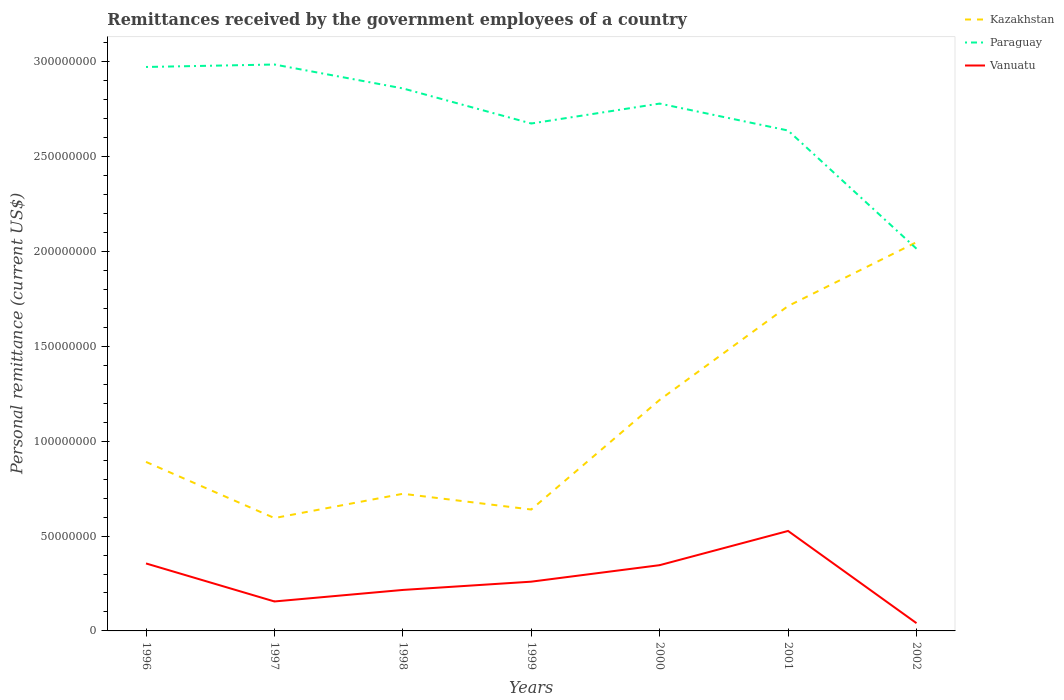Does the line corresponding to Kazakhstan intersect with the line corresponding to Vanuatu?
Make the answer very short. No. Across all years, what is the maximum remittances received by the government employees in Vanuatu?
Provide a short and direct response. 4.10e+06. What is the total remittances received by the government employees in Paraguay in the graph?
Your answer should be very brief. 3.70e+06. What is the difference between the highest and the second highest remittances received by the government employees in Paraguay?
Your answer should be very brief. 9.71e+07. How many lines are there?
Provide a succinct answer. 3. How many years are there in the graph?
Give a very brief answer. 7. Are the values on the major ticks of Y-axis written in scientific E-notation?
Provide a succinct answer. No. Where does the legend appear in the graph?
Offer a terse response. Top right. How are the legend labels stacked?
Give a very brief answer. Vertical. What is the title of the graph?
Offer a terse response. Remittances received by the government employees of a country. Does "Trinidad and Tobago" appear as one of the legend labels in the graph?
Offer a terse response. No. What is the label or title of the Y-axis?
Your answer should be compact. Personal remittance (current US$). What is the Personal remittance (current US$) of Kazakhstan in 1996?
Make the answer very short. 8.91e+07. What is the Personal remittance (current US$) in Paraguay in 1996?
Give a very brief answer. 2.97e+08. What is the Personal remittance (current US$) in Vanuatu in 1996?
Your response must be concise. 3.56e+07. What is the Personal remittance (current US$) of Kazakhstan in 1997?
Give a very brief answer. 5.95e+07. What is the Personal remittance (current US$) of Paraguay in 1997?
Offer a terse response. 2.99e+08. What is the Personal remittance (current US$) in Vanuatu in 1997?
Provide a short and direct response. 1.55e+07. What is the Personal remittance (current US$) of Kazakhstan in 1998?
Your answer should be very brief. 7.23e+07. What is the Personal remittance (current US$) in Paraguay in 1998?
Ensure brevity in your answer.  2.86e+08. What is the Personal remittance (current US$) of Vanuatu in 1998?
Your answer should be compact. 2.16e+07. What is the Personal remittance (current US$) of Kazakhstan in 1999?
Provide a succinct answer. 6.40e+07. What is the Personal remittance (current US$) of Paraguay in 1999?
Provide a short and direct response. 2.68e+08. What is the Personal remittance (current US$) of Vanuatu in 1999?
Provide a succinct answer. 2.60e+07. What is the Personal remittance (current US$) of Kazakhstan in 2000?
Make the answer very short. 1.22e+08. What is the Personal remittance (current US$) of Paraguay in 2000?
Your answer should be compact. 2.78e+08. What is the Personal remittance (current US$) of Vanuatu in 2000?
Give a very brief answer. 3.47e+07. What is the Personal remittance (current US$) in Kazakhstan in 2001?
Make the answer very short. 1.71e+08. What is the Personal remittance (current US$) in Paraguay in 2001?
Provide a short and direct response. 2.64e+08. What is the Personal remittance (current US$) of Vanuatu in 2001?
Keep it short and to the point. 5.27e+07. What is the Personal remittance (current US$) in Kazakhstan in 2002?
Ensure brevity in your answer.  2.05e+08. What is the Personal remittance (current US$) of Paraguay in 2002?
Ensure brevity in your answer.  2.02e+08. What is the Personal remittance (current US$) in Vanuatu in 2002?
Provide a short and direct response. 4.10e+06. Across all years, what is the maximum Personal remittance (current US$) of Kazakhstan?
Your answer should be very brief. 2.05e+08. Across all years, what is the maximum Personal remittance (current US$) in Paraguay?
Provide a short and direct response. 2.99e+08. Across all years, what is the maximum Personal remittance (current US$) of Vanuatu?
Your answer should be compact. 5.27e+07. Across all years, what is the minimum Personal remittance (current US$) in Kazakhstan?
Provide a succinct answer. 5.95e+07. Across all years, what is the minimum Personal remittance (current US$) in Paraguay?
Your response must be concise. 2.02e+08. Across all years, what is the minimum Personal remittance (current US$) of Vanuatu?
Ensure brevity in your answer.  4.10e+06. What is the total Personal remittance (current US$) of Kazakhstan in the graph?
Offer a very short reply. 7.83e+08. What is the total Personal remittance (current US$) of Paraguay in the graph?
Offer a very short reply. 1.89e+09. What is the total Personal remittance (current US$) in Vanuatu in the graph?
Ensure brevity in your answer.  1.90e+08. What is the difference between the Personal remittance (current US$) of Kazakhstan in 1996 and that in 1997?
Make the answer very short. 2.96e+07. What is the difference between the Personal remittance (current US$) in Paraguay in 1996 and that in 1997?
Provide a succinct answer. -1.30e+06. What is the difference between the Personal remittance (current US$) in Vanuatu in 1996 and that in 1997?
Offer a very short reply. 2.00e+07. What is the difference between the Personal remittance (current US$) in Kazakhstan in 1996 and that in 1998?
Ensure brevity in your answer.  1.68e+07. What is the difference between the Personal remittance (current US$) of Paraguay in 1996 and that in 1998?
Offer a very short reply. 1.13e+07. What is the difference between the Personal remittance (current US$) in Vanuatu in 1996 and that in 1998?
Ensure brevity in your answer.  1.40e+07. What is the difference between the Personal remittance (current US$) of Kazakhstan in 1996 and that in 1999?
Your answer should be very brief. 2.51e+07. What is the difference between the Personal remittance (current US$) of Paraguay in 1996 and that in 1999?
Give a very brief answer. 2.98e+07. What is the difference between the Personal remittance (current US$) in Vanuatu in 1996 and that in 1999?
Provide a succinct answer. 9.60e+06. What is the difference between the Personal remittance (current US$) of Kazakhstan in 1996 and that in 2000?
Provide a succinct answer. -3.27e+07. What is the difference between the Personal remittance (current US$) of Paraguay in 1996 and that in 2000?
Offer a terse response. 1.93e+07. What is the difference between the Personal remittance (current US$) of Vanuatu in 1996 and that in 2000?
Provide a succinct answer. 9.06e+05. What is the difference between the Personal remittance (current US$) in Kazakhstan in 1996 and that in 2001?
Provide a succinct answer. -8.22e+07. What is the difference between the Personal remittance (current US$) of Paraguay in 1996 and that in 2001?
Ensure brevity in your answer.  3.35e+07. What is the difference between the Personal remittance (current US$) in Vanuatu in 1996 and that in 2001?
Give a very brief answer. -1.71e+07. What is the difference between the Personal remittance (current US$) of Kazakhstan in 1996 and that in 2002?
Offer a very short reply. -1.16e+08. What is the difference between the Personal remittance (current US$) in Paraguay in 1996 and that in 2002?
Keep it short and to the point. 9.58e+07. What is the difference between the Personal remittance (current US$) of Vanuatu in 1996 and that in 2002?
Offer a very short reply. 3.15e+07. What is the difference between the Personal remittance (current US$) in Kazakhstan in 1997 and that in 1998?
Your response must be concise. -1.28e+07. What is the difference between the Personal remittance (current US$) in Paraguay in 1997 and that in 1998?
Provide a succinct answer. 1.26e+07. What is the difference between the Personal remittance (current US$) of Vanuatu in 1997 and that in 1998?
Your answer should be compact. -6.08e+06. What is the difference between the Personal remittance (current US$) in Kazakhstan in 1997 and that in 1999?
Make the answer very short. -4.50e+06. What is the difference between the Personal remittance (current US$) in Paraguay in 1997 and that in 1999?
Keep it short and to the point. 3.11e+07. What is the difference between the Personal remittance (current US$) in Vanuatu in 1997 and that in 1999?
Keep it short and to the point. -1.04e+07. What is the difference between the Personal remittance (current US$) in Kazakhstan in 1997 and that in 2000?
Your response must be concise. -6.23e+07. What is the difference between the Personal remittance (current US$) in Paraguay in 1997 and that in 2000?
Keep it short and to the point. 2.06e+07. What is the difference between the Personal remittance (current US$) of Vanuatu in 1997 and that in 2000?
Your answer should be compact. -1.91e+07. What is the difference between the Personal remittance (current US$) in Kazakhstan in 1997 and that in 2001?
Provide a succinct answer. -1.12e+08. What is the difference between the Personal remittance (current US$) in Paraguay in 1997 and that in 2001?
Offer a very short reply. 3.48e+07. What is the difference between the Personal remittance (current US$) in Vanuatu in 1997 and that in 2001?
Ensure brevity in your answer.  -3.72e+07. What is the difference between the Personal remittance (current US$) in Kazakhstan in 1997 and that in 2002?
Offer a terse response. -1.45e+08. What is the difference between the Personal remittance (current US$) of Paraguay in 1997 and that in 2002?
Provide a short and direct response. 9.71e+07. What is the difference between the Personal remittance (current US$) in Vanuatu in 1997 and that in 2002?
Offer a terse response. 1.14e+07. What is the difference between the Personal remittance (current US$) of Kazakhstan in 1998 and that in 1999?
Ensure brevity in your answer.  8.30e+06. What is the difference between the Personal remittance (current US$) of Paraguay in 1998 and that in 1999?
Provide a succinct answer. 1.85e+07. What is the difference between the Personal remittance (current US$) of Vanuatu in 1998 and that in 1999?
Keep it short and to the point. -4.36e+06. What is the difference between the Personal remittance (current US$) of Kazakhstan in 1998 and that in 2000?
Ensure brevity in your answer.  -4.95e+07. What is the difference between the Personal remittance (current US$) of Vanuatu in 1998 and that in 2000?
Keep it short and to the point. -1.31e+07. What is the difference between the Personal remittance (current US$) in Kazakhstan in 1998 and that in 2001?
Offer a terse response. -9.90e+07. What is the difference between the Personal remittance (current US$) of Paraguay in 1998 and that in 2001?
Offer a very short reply. 2.22e+07. What is the difference between the Personal remittance (current US$) in Vanuatu in 1998 and that in 2001?
Your answer should be compact. -3.11e+07. What is the difference between the Personal remittance (current US$) in Kazakhstan in 1998 and that in 2002?
Your answer should be compact. -1.33e+08. What is the difference between the Personal remittance (current US$) of Paraguay in 1998 and that in 2002?
Your response must be concise. 8.45e+07. What is the difference between the Personal remittance (current US$) in Vanuatu in 1998 and that in 2002?
Offer a terse response. 1.75e+07. What is the difference between the Personal remittance (current US$) in Kazakhstan in 1999 and that in 2000?
Offer a terse response. -5.78e+07. What is the difference between the Personal remittance (current US$) in Paraguay in 1999 and that in 2000?
Your response must be concise. -1.05e+07. What is the difference between the Personal remittance (current US$) in Vanuatu in 1999 and that in 2000?
Keep it short and to the point. -8.70e+06. What is the difference between the Personal remittance (current US$) of Kazakhstan in 1999 and that in 2001?
Your answer should be compact. -1.07e+08. What is the difference between the Personal remittance (current US$) of Paraguay in 1999 and that in 2001?
Offer a very short reply. 3.70e+06. What is the difference between the Personal remittance (current US$) in Vanuatu in 1999 and that in 2001?
Your response must be concise. -2.67e+07. What is the difference between the Personal remittance (current US$) of Kazakhstan in 1999 and that in 2002?
Ensure brevity in your answer.  -1.41e+08. What is the difference between the Personal remittance (current US$) of Paraguay in 1999 and that in 2002?
Provide a succinct answer. 6.60e+07. What is the difference between the Personal remittance (current US$) of Vanuatu in 1999 and that in 2002?
Provide a short and direct response. 2.19e+07. What is the difference between the Personal remittance (current US$) of Kazakhstan in 2000 and that in 2001?
Make the answer very short. -4.95e+07. What is the difference between the Personal remittance (current US$) of Paraguay in 2000 and that in 2001?
Offer a very short reply. 1.42e+07. What is the difference between the Personal remittance (current US$) of Vanuatu in 2000 and that in 2001?
Your answer should be compact. -1.80e+07. What is the difference between the Personal remittance (current US$) in Kazakhstan in 2000 and that in 2002?
Give a very brief answer. -8.31e+07. What is the difference between the Personal remittance (current US$) of Paraguay in 2000 and that in 2002?
Your answer should be very brief. 7.65e+07. What is the difference between the Personal remittance (current US$) in Vanuatu in 2000 and that in 2002?
Your answer should be very brief. 3.06e+07. What is the difference between the Personal remittance (current US$) in Kazakhstan in 2001 and that in 2002?
Your answer should be compact. -3.37e+07. What is the difference between the Personal remittance (current US$) in Paraguay in 2001 and that in 2002?
Your answer should be very brief. 6.23e+07. What is the difference between the Personal remittance (current US$) in Vanuatu in 2001 and that in 2002?
Your answer should be very brief. 4.86e+07. What is the difference between the Personal remittance (current US$) in Kazakhstan in 1996 and the Personal remittance (current US$) in Paraguay in 1997?
Your answer should be compact. -2.10e+08. What is the difference between the Personal remittance (current US$) of Kazakhstan in 1996 and the Personal remittance (current US$) of Vanuatu in 1997?
Make the answer very short. 7.36e+07. What is the difference between the Personal remittance (current US$) of Paraguay in 1996 and the Personal remittance (current US$) of Vanuatu in 1997?
Make the answer very short. 2.82e+08. What is the difference between the Personal remittance (current US$) of Kazakhstan in 1996 and the Personal remittance (current US$) of Paraguay in 1998?
Offer a very short reply. -1.97e+08. What is the difference between the Personal remittance (current US$) of Kazakhstan in 1996 and the Personal remittance (current US$) of Vanuatu in 1998?
Your answer should be very brief. 6.75e+07. What is the difference between the Personal remittance (current US$) in Paraguay in 1996 and the Personal remittance (current US$) in Vanuatu in 1998?
Offer a terse response. 2.76e+08. What is the difference between the Personal remittance (current US$) in Kazakhstan in 1996 and the Personal remittance (current US$) in Paraguay in 1999?
Offer a very short reply. -1.78e+08. What is the difference between the Personal remittance (current US$) of Kazakhstan in 1996 and the Personal remittance (current US$) of Vanuatu in 1999?
Your response must be concise. 6.31e+07. What is the difference between the Personal remittance (current US$) of Paraguay in 1996 and the Personal remittance (current US$) of Vanuatu in 1999?
Your response must be concise. 2.71e+08. What is the difference between the Personal remittance (current US$) in Kazakhstan in 1996 and the Personal remittance (current US$) in Paraguay in 2000?
Offer a terse response. -1.89e+08. What is the difference between the Personal remittance (current US$) of Kazakhstan in 1996 and the Personal remittance (current US$) of Vanuatu in 2000?
Your answer should be very brief. 5.44e+07. What is the difference between the Personal remittance (current US$) of Paraguay in 1996 and the Personal remittance (current US$) of Vanuatu in 2000?
Your answer should be very brief. 2.63e+08. What is the difference between the Personal remittance (current US$) in Kazakhstan in 1996 and the Personal remittance (current US$) in Paraguay in 2001?
Provide a succinct answer. -1.75e+08. What is the difference between the Personal remittance (current US$) in Kazakhstan in 1996 and the Personal remittance (current US$) in Vanuatu in 2001?
Offer a terse response. 3.64e+07. What is the difference between the Personal remittance (current US$) in Paraguay in 1996 and the Personal remittance (current US$) in Vanuatu in 2001?
Make the answer very short. 2.45e+08. What is the difference between the Personal remittance (current US$) of Kazakhstan in 1996 and the Personal remittance (current US$) of Paraguay in 2002?
Make the answer very short. -1.12e+08. What is the difference between the Personal remittance (current US$) in Kazakhstan in 1996 and the Personal remittance (current US$) in Vanuatu in 2002?
Give a very brief answer. 8.50e+07. What is the difference between the Personal remittance (current US$) of Paraguay in 1996 and the Personal remittance (current US$) of Vanuatu in 2002?
Your response must be concise. 2.93e+08. What is the difference between the Personal remittance (current US$) of Kazakhstan in 1997 and the Personal remittance (current US$) of Paraguay in 1998?
Your answer should be very brief. -2.26e+08. What is the difference between the Personal remittance (current US$) of Kazakhstan in 1997 and the Personal remittance (current US$) of Vanuatu in 1998?
Keep it short and to the point. 3.79e+07. What is the difference between the Personal remittance (current US$) in Paraguay in 1997 and the Personal remittance (current US$) in Vanuatu in 1998?
Your answer should be very brief. 2.77e+08. What is the difference between the Personal remittance (current US$) in Kazakhstan in 1997 and the Personal remittance (current US$) in Paraguay in 1999?
Provide a succinct answer. -2.08e+08. What is the difference between the Personal remittance (current US$) of Kazakhstan in 1997 and the Personal remittance (current US$) of Vanuatu in 1999?
Your answer should be very brief. 3.35e+07. What is the difference between the Personal remittance (current US$) in Paraguay in 1997 and the Personal remittance (current US$) in Vanuatu in 1999?
Give a very brief answer. 2.73e+08. What is the difference between the Personal remittance (current US$) in Kazakhstan in 1997 and the Personal remittance (current US$) in Paraguay in 2000?
Ensure brevity in your answer.  -2.18e+08. What is the difference between the Personal remittance (current US$) in Kazakhstan in 1997 and the Personal remittance (current US$) in Vanuatu in 2000?
Your answer should be very brief. 2.48e+07. What is the difference between the Personal remittance (current US$) of Paraguay in 1997 and the Personal remittance (current US$) of Vanuatu in 2000?
Keep it short and to the point. 2.64e+08. What is the difference between the Personal remittance (current US$) of Kazakhstan in 1997 and the Personal remittance (current US$) of Paraguay in 2001?
Your answer should be compact. -2.04e+08. What is the difference between the Personal remittance (current US$) of Kazakhstan in 1997 and the Personal remittance (current US$) of Vanuatu in 2001?
Make the answer very short. 6.80e+06. What is the difference between the Personal remittance (current US$) of Paraguay in 1997 and the Personal remittance (current US$) of Vanuatu in 2001?
Make the answer very short. 2.46e+08. What is the difference between the Personal remittance (current US$) in Kazakhstan in 1997 and the Personal remittance (current US$) in Paraguay in 2002?
Provide a succinct answer. -1.42e+08. What is the difference between the Personal remittance (current US$) of Kazakhstan in 1997 and the Personal remittance (current US$) of Vanuatu in 2002?
Your answer should be very brief. 5.54e+07. What is the difference between the Personal remittance (current US$) in Paraguay in 1997 and the Personal remittance (current US$) in Vanuatu in 2002?
Offer a very short reply. 2.95e+08. What is the difference between the Personal remittance (current US$) in Kazakhstan in 1998 and the Personal remittance (current US$) in Paraguay in 1999?
Your answer should be very brief. -1.95e+08. What is the difference between the Personal remittance (current US$) of Kazakhstan in 1998 and the Personal remittance (current US$) of Vanuatu in 1999?
Give a very brief answer. 4.63e+07. What is the difference between the Personal remittance (current US$) in Paraguay in 1998 and the Personal remittance (current US$) in Vanuatu in 1999?
Your response must be concise. 2.60e+08. What is the difference between the Personal remittance (current US$) in Kazakhstan in 1998 and the Personal remittance (current US$) in Paraguay in 2000?
Provide a short and direct response. -2.06e+08. What is the difference between the Personal remittance (current US$) of Kazakhstan in 1998 and the Personal remittance (current US$) of Vanuatu in 2000?
Your response must be concise. 3.76e+07. What is the difference between the Personal remittance (current US$) of Paraguay in 1998 and the Personal remittance (current US$) of Vanuatu in 2000?
Keep it short and to the point. 2.51e+08. What is the difference between the Personal remittance (current US$) in Kazakhstan in 1998 and the Personal remittance (current US$) in Paraguay in 2001?
Your answer should be very brief. -1.91e+08. What is the difference between the Personal remittance (current US$) of Kazakhstan in 1998 and the Personal remittance (current US$) of Vanuatu in 2001?
Provide a short and direct response. 1.96e+07. What is the difference between the Personal remittance (current US$) in Paraguay in 1998 and the Personal remittance (current US$) in Vanuatu in 2001?
Offer a terse response. 2.33e+08. What is the difference between the Personal remittance (current US$) in Kazakhstan in 1998 and the Personal remittance (current US$) in Paraguay in 2002?
Offer a terse response. -1.29e+08. What is the difference between the Personal remittance (current US$) in Kazakhstan in 1998 and the Personal remittance (current US$) in Vanuatu in 2002?
Your response must be concise. 6.82e+07. What is the difference between the Personal remittance (current US$) of Paraguay in 1998 and the Personal remittance (current US$) of Vanuatu in 2002?
Make the answer very short. 2.82e+08. What is the difference between the Personal remittance (current US$) of Kazakhstan in 1999 and the Personal remittance (current US$) of Paraguay in 2000?
Your answer should be compact. -2.14e+08. What is the difference between the Personal remittance (current US$) of Kazakhstan in 1999 and the Personal remittance (current US$) of Vanuatu in 2000?
Provide a short and direct response. 2.93e+07. What is the difference between the Personal remittance (current US$) in Paraguay in 1999 and the Personal remittance (current US$) in Vanuatu in 2000?
Keep it short and to the point. 2.33e+08. What is the difference between the Personal remittance (current US$) in Kazakhstan in 1999 and the Personal remittance (current US$) in Paraguay in 2001?
Your answer should be very brief. -2.00e+08. What is the difference between the Personal remittance (current US$) of Kazakhstan in 1999 and the Personal remittance (current US$) of Vanuatu in 2001?
Your answer should be very brief. 1.13e+07. What is the difference between the Personal remittance (current US$) in Paraguay in 1999 and the Personal remittance (current US$) in Vanuatu in 2001?
Provide a short and direct response. 2.15e+08. What is the difference between the Personal remittance (current US$) in Kazakhstan in 1999 and the Personal remittance (current US$) in Paraguay in 2002?
Offer a very short reply. -1.38e+08. What is the difference between the Personal remittance (current US$) of Kazakhstan in 1999 and the Personal remittance (current US$) of Vanuatu in 2002?
Make the answer very short. 5.99e+07. What is the difference between the Personal remittance (current US$) of Paraguay in 1999 and the Personal remittance (current US$) of Vanuatu in 2002?
Your answer should be very brief. 2.63e+08. What is the difference between the Personal remittance (current US$) of Kazakhstan in 2000 and the Personal remittance (current US$) of Paraguay in 2001?
Your answer should be very brief. -1.42e+08. What is the difference between the Personal remittance (current US$) in Kazakhstan in 2000 and the Personal remittance (current US$) in Vanuatu in 2001?
Offer a terse response. 6.91e+07. What is the difference between the Personal remittance (current US$) in Paraguay in 2000 and the Personal remittance (current US$) in Vanuatu in 2001?
Give a very brief answer. 2.25e+08. What is the difference between the Personal remittance (current US$) of Kazakhstan in 2000 and the Personal remittance (current US$) of Paraguay in 2002?
Keep it short and to the point. -7.97e+07. What is the difference between the Personal remittance (current US$) in Kazakhstan in 2000 and the Personal remittance (current US$) in Vanuatu in 2002?
Give a very brief answer. 1.18e+08. What is the difference between the Personal remittance (current US$) in Paraguay in 2000 and the Personal remittance (current US$) in Vanuatu in 2002?
Provide a short and direct response. 2.74e+08. What is the difference between the Personal remittance (current US$) of Kazakhstan in 2001 and the Personal remittance (current US$) of Paraguay in 2002?
Your answer should be compact. -3.02e+07. What is the difference between the Personal remittance (current US$) in Kazakhstan in 2001 and the Personal remittance (current US$) in Vanuatu in 2002?
Offer a terse response. 1.67e+08. What is the difference between the Personal remittance (current US$) in Paraguay in 2001 and the Personal remittance (current US$) in Vanuatu in 2002?
Keep it short and to the point. 2.60e+08. What is the average Personal remittance (current US$) in Kazakhstan per year?
Your answer should be very brief. 1.12e+08. What is the average Personal remittance (current US$) of Paraguay per year?
Keep it short and to the point. 2.70e+08. What is the average Personal remittance (current US$) of Vanuatu per year?
Provide a succinct answer. 2.72e+07. In the year 1996, what is the difference between the Personal remittance (current US$) of Kazakhstan and Personal remittance (current US$) of Paraguay?
Offer a terse response. -2.08e+08. In the year 1996, what is the difference between the Personal remittance (current US$) of Kazakhstan and Personal remittance (current US$) of Vanuatu?
Offer a terse response. 5.35e+07. In the year 1996, what is the difference between the Personal remittance (current US$) of Paraguay and Personal remittance (current US$) of Vanuatu?
Offer a terse response. 2.62e+08. In the year 1997, what is the difference between the Personal remittance (current US$) of Kazakhstan and Personal remittance (current US$) of Paraguay?
Give a very brief answer. -2.39e+08. In the year 1997, what is the difference between the Personal remittance (current US$) of Kazakhstan and Personal remittance (current US$) of Vanuatu?
Offer a very short reply. 4.40e+07. In the year 1997, what is the difference between the Personal remittance (current US$) of Paraguay and Personal remittance (current US$) of Vanuatu?
Your answer should be compact. 2.83e+08. In the year 1998, what is the difference between the Personal remittance (current US$) in Kazakhstan and Personal remittance (current US$) in Paraguay?
Your response must be concise. -2.14e+08. In the year 1998, what is the difference between the Personal remittance (current US$) of Kazakhstan and Personal remittance (current US$) of Vanuatu?
Ensure brevity in your answer.  5.07e+07. In the year 1998, what is the difference between the Personal remittance (current US$) in Paraguay and Personal remittance (current US$) in Vanuatu?
Your response must be concise. 2.64e+08. In the year 1999, what is the difference between the Personal remittance (current US$) in Kazakhstan and Personal remittance (current US$) in Paraguay?
Provide a succinct answer. -2.04e+08. In the year 1999, what is the difference between the Personal remittance (current US$) of Kazakhstan and Personal remittance (current US$) of Vanuatu?
Offer a very short reply. 3.80e+07. In the year 1999, what is the difference between the Personal remittance (current US$) in Paraguay and Personal remittance (current US$) in Vanuatu?
Offer a terse response. 2.42e+08. In the year 2000, what is the difference between the Personal remittance (current US$) of Kazakhstan and Personal remittance (current US$) of Paraguay?
Offer a terse response. -1.56e+08. In the year 2000, what is the difference between the Personal remittance (current US$) of Kazakhstan and Personal remittance (current US$) of Vanuatu?
Your answer should be compact. 8.71e+07. In the year 2000, what is the difference between the Personal remittance (current US$) of Paraguay and Personal remittance (current US$) of Vanuatu?
Offer a very short reply. 2.43e+08. In the year 2001, what is the difference between the Personal remittance (current US$) in Kazakhstan and Personal remittance (current US$) in Paraguay?
Offer a very short reply. -9.25e+07. In the year 2001, what is the difference between the Personal remittance (current US$) of Kazakhstan and Personal remittance (current US$) of Vanuatu?
Provide a short and direct response. 1.19e+08. In the year 2001, what is the difference between the Personal remittance (current US$) of Paraguay and Personal remittance (current US$) of Vanuatu?
Your answer should be compact. 2.11e+08. In the year 2002, what is the difference between the Personal remittance (current US$) of Kazakhstan and Personal remittance (current US$) of Paraguay?
Your answer should be compact. 3.43e+06. In the year 2002, what is the difference between the Personal remittance (current US$) in Kazakhstan and Personal remittance (current US$) in Vanuatu?
Provide a succinct answer. 2.01e+08. In the year 2002, what is the difference between the Personal remittance (current US$) in Paraguay and Personal remittance (current US$) in Vanuatu?
Make the answer very short. 1.97e+08. What is the ratio of the Personal remittance (current US$) of Kazakhstan in 1996 to that in 1997?
Give a very brief answer. 1.5. What is the ratio of the Personal remittance (current US$) in Vanuatu in 1996 to that in 1997?
Provide a succinct answer. 2.29. What is the ratio of the Personal remittance (current US$) in Kazakhstan in 1996 to that in 1998?
Keep it short and to the point. 1.23. What is the ratio of the Personal remittance (current US$) of Paraguay in 1996 to that in 1998?
Provide a short and direct response. 1.04. What is the ratio of the Personal remittance (current US$) in Vanuatu in 1996 to that in 1998?
Provide a succinct answer. 1.65. What is the ratio of the Personal remittance (current US$) in Kazakhstan in 1996 to that in 1999?
Your response must be concise. 1.39. What is the ratio of the Personal remittance (current US$) of Paraguay in 1996 to that in 1999?
Your answer should be compact. 1.11. What is the ratio of the Personal remittance (current US$) in Vanuatu in 1996 to that in 1999?
Your response must be concise. 1.37. What is the ratio of the Personal remittance (current US$) of Kazakhstan in 1996 to that in 2000?
Your answer should be very brief. 0.73. What is the ratio of the Personal remittance (current US$) of Paraguay in 1996 to that in 2000?
Your answer should be compact. 1.07. What is the ratio of the Personal remittance (current US$) in Vanuatu in 1996 to that in 2000?
Offer a terse response. 1.03. What is the ratio of the Personal remittance (current US$) in Kazakhstan in 1996 to that in 2001?
Offer a very short reply. 0.52. What is the ratio of the Personal remittance (current US$) in Paraguay in 1996 to that in 2001?
Your answer should be compact. 1.13. What is the ratio of the Personal remittance (current US$) of Vanuatu in 1996 to that in 2001?
Offer a very short reply. 0.67. What is the ratio of the Personal remittance (current US$) of Kazakhstan in 1996 to that in 2002?
Your answer should be very brief. 0.43. What is the ratio of the Personal remittance (current US$) in Paraguay in 1996 to that in 2002?
Keep it short and to the point. 1.48. What is the ratio of the Personal remittance (current US$) of Vanuatu in 1996 to that in 2002?
Offer a terse response. 8.68. What is the ratio of the Personal remittance (current US$) in Kazakhstan in 1997 to that in 1998?
Keep it short and to the point. 0.82. What is the ratio of the Personal remittance (current US$) of Paraguay in 1997 to that in 1998?
Your answer should be compact. 1.04. What is the ratio of the Personal remittance (current US$) in Vanuatu in 1997 to that in 1998?
Your answer should be compact. 0.72. What is the ratio of the Personal remittance (current US$) of Kazakhstan in 1997 to that in 1999?
Offer a terse response. 0.93. What is the ratio of the Personal remittance (current US$) of Paraguay in 1997 to that in 1999?
Your answer should be compact. 1.12. What is the ratio of the Personal remittance (current US$) of Vanuatu in 1997 to that in 1999?
Provide a succinct answer. 0.6. What is the ratio of the Personal remittance (current US$) of Kazakhstan in 1997 to that in 2000?
Provide a short and direct response. 0.49. What is the ratio of the Personal remittance (current US$) in Paraguay in 1997 to that in 2000?
Make the answer very short. 1.07. What is the ratio of the Personal remittance (current US$) in Vanuatu in 1997 to that in 2000?
Make the answer very short. 0.45. What is the ratio of the Personal remittance (current US$) of Kazakhstan in 1997 to that in 2001?
Keep it short and to the point. 0.35. What is the ratio of the Personal remittance (current US$) of Paraguay in 1997 to that in 2001?
Provide a short and direct response. 1.13. What is the ratio of the Personal remittance (current US$) in Vanuatu in 1997 to that in 2001?
Keep it short and to the point. 0.29. What is the ratio of the Personal remittance (current US$) in Kazakhstan in 1997 to that in 2002?
Provide a short and direct response. 0.29. What is the ratio of the Personal remittance (current US$) in Paraguay in 1997 to that in 2002?
Offer a very short reply. 1.48. What is the ratio of the Personal remittance (current US$) of Vanuatu in 1997 to that in 2002?
Your answer should be compact. 3.79. What is the ratio of the Personal remittance (current US$) in Kazakhstan in 1998 to that in 1999?
Offer a very short reply. 1.13. What is the ratio of the Personal remittance (current US$) of Paraguay in 1998 to that in 1999?
Offer a terse response. 1.07. What is the ratio of the Personal remittance (current US$) of Vanuatu in 1998 to that in 1999?
Make the answer very short. 0.83. What is the ratio of the Personal remittance (current US$) of Kazakhstan in 1998 to that in 2000?
Keep it short and to the point. 0.59. What is the ratio of the Personal remittance (current US$) in Paraguay in 1998 to that in 2000?
Your answer should be compact. 1.03. What is the ratio of the Personal remittance (current US$) in Vanuatu in 1998 to that in 2000?
Ensure brevity in your answer.  0.62. What is the ratio of the Personal remittance (current US$) of Kazakhstan in 1998 to that in 2001?
Give a very brief answer. 0.42. What is the ratio of the Personal remittance (current US$) of Paraguay in 1998 to that in 2001?
Give a very brief answer. 1.08. What is the ratio of the Personal remittance (current US$) in Vanuatu in 1998 to that in 2001?
Provide a short and direct response. 0.41. What is the ratio of the Personal remittance (current US$) of Kazakhstan in 1998 to that in 2002?
Keep it short and to the point. 0.35. What is the ratio of the Personal remittance (current US$) of Paraguay in 1998 to that in 2002?
Your answer should be compact. 1.42. What is the ratio of the Personal remittance (current US$) of Vanuatu in 1998 to that in 2002?
Provide a succinct answer. 5.27. What is the ratio of the Personal remittance (current US$) of Kazakhstan in 1999 to that in 2000?
Make the answer very short. 0.53. What is the ratio of the Personal remittance (current US$) of Paraguay in 1999 to that in 2000?
Ensure brevity in your answer.  0.96. What is the ratio of the Personal remittance (current US$) of Vanuatu in 1999 to that in 2000?
Ensure brevity in your answer.  0.75. What is the ratio of the Personal remittance (current US$) in Kazakhstan in 1999 to that in 2001?
Offer a very short reply. 0.37. What is the ratio of the Personal remittance (current US$) in Paraguay in 1999 to that in 2001?
Your answer should be very brief. 1.01. What is the ratio of the Personal remittance (current US$) of Vanuatu in 1999 to that in 2001?
Your answer should be very brief. 0.49. What is the ratio of the Personal remittance (current US$) of Kazakhstan in 1999 to that in 2002?
Your response must be concise. 0.31. What is the ratio of the Personal remittance (current US$) in Paraguay in 1999 to that in 2002?
Ensure brevity in your answer.  1.33. What is the ratio of the Personal remittance (current US$) of Vanuatu in 1999 to that in 2002?
Keep it short and to the point. 6.34. What is the ratio of the Personal remittance (current US$) in Kazakhstan in 2000 to that in 2001?
Keep it short and to the point. 0.71. What is the ratio of the Personal remittance (current US$) in Paraguay in 2000 to that in 2001?
Give a very brief answer. 1.05. What is the ratio of the Personal remittance (current US$) of Vanuatu in 2000 to that in 2001?
Your answer should be very brief. 0.66. What is the ratio of the Personal remittance (current US$) in Kazakhstan in 2000 to that in 2002?
Offer a terse response. 0.59. What is the ratio of the Personal remittance (current US$) in Paraguay in 2000 to that in 2002?
Your answer should be compact. 1.38. What is the ratio of the Personal remittance (current US$) in Vanuatu in 2000 to that in 2002?
Ensure brevity in your answer.  8.46. What is the ratio of the Personal remittance (current US$) in Kazakhstan in 2001 to that in 2002?
Your answer should be compact. 0.84. What is the ratio of the Personal remittance (current US$) of Paraguay in 2001 to that in 2002?
Give a very brief answer. 1.31. What is the ratio of the Personal remittance (current US$) of Vanuatu in 2001 to that in 2002?
Offer a terse response. 12.86. What is the difference between the highest and the second highest Personal remittance (current US$) of Kazakhstan?
Make the answer very short. 3.37e+07. What is the difference between the highest and the second highest Personal remittance (current US$) in Paraguay?
Offer a terse response. 1.30e+06. What is the difference between the highest and the second highest Personal remittance (current US$) of Vanuatu?
Offer a very short reply. 1.71e+07. What is the difference between the highest and the lowest Personal remittance (current US$) of Kazakhstan?
Your answer should be compact. 1.45e+08. What is the difference between the highest and the lowest Personal remittance (current US$) in Paraguay?
Your answer should be very brief. 9.71e+07. What is the difference between the highest and the lowest Personal remittance (current US$) of Vanuatu?
Offer a terse response. 4.86e+07. 